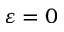Convert formula to latex. <formula><loc_0><loc_0><loc_500><loc_500>\varepsilon = 0</formula> 